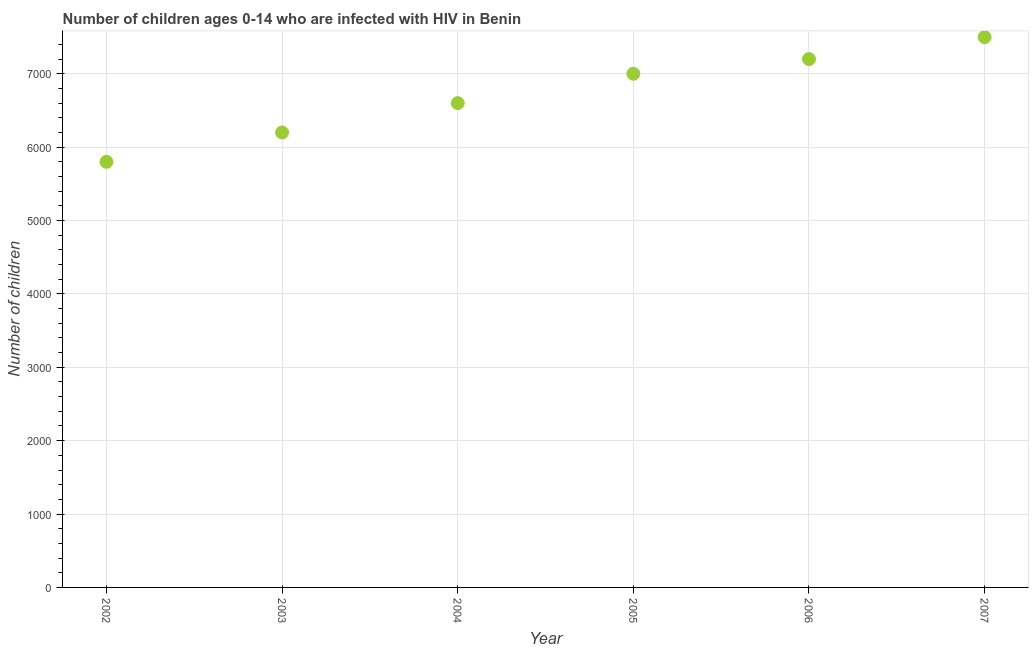What is the number of children living with hiv in 2007?
Offer a very short reply. 7500. Across all years, what is the maximum number of children living with hiv?
Keep it short and to the point. 7500. Across all years, what is the minimum number of children living with hiv?
Make the answer very short. 5800. What is the sum of the number of children living with hiv?
Your answer should be compact. 4.03e+04. What is the difference between the number of children living with hiv in 2004 and 2006?
Offer a very short reply. -600. What is the average number of children living with hiv per year?
Offer a terse response. 6716.67. What is the median number of children living with hiv?
Provide a succinct answer. 6800. Do a majority of the years between 2004 and 2007 (inclusive) have number of children living with hiv greater than 4800 ?
Keep it short and to the point. Yes. What is the ratio of the number of children living with hiv in 2005 to that in 2006?
Make the answer very short. 0.97. Is the difference between the number of children living with hiv in 2003 and 2006 greater than the difference between any two years?
Provide a succinct answer. No. What is the difference between the highest and the second highest number of children living with hiv?
Your response must be concise. 300. What is the difference between the highest and the lowest number of children living with hiv?
Your answer should be compact. 1700. In how many years, is the number of children living with hiv greater than the average number of children living with hiv taken over all years?
Your answer should be compact. 3. Does the number of children living with hiv monotonically increase over the years?
Ensure brevity in your answer.  Yes. What is the difference between two consecutive major ticks on the Y-axis?
Provide a short and direct response. 1000. Are the values on the major ticks of Y-axis written in scientific E-notation?
Your response must be concise. No. Does the graph contain any zero values?
Your answer should be compact. No. Does the graph contain grids?
Make the answer very short. Yes. What is the title of the graph?
Provide a succinct answer. Number of children ages 0-14 who are infected with HIV in Benin. What is the label or title of the X-axis?
Provide a succinct answer. Year. What is the label or title of the Y-axis?
Keep it short and to the point. Number of children. What is the Number of children in 2002?
Offer a terse response. 5800. What is the Number of children in 2003?
Offer a terse response. 6200. What is the Number of children in 2004?
Offer a terse response. 6600. What is the Number of children in 2005?
Provide a short and direct response. 7000. What is the Number of children in 2006?
Ensure brevity in your answer.  7200. What is the Number of children in 2007?
Your answer should be very brief. 7500. What is the difference between the Number of children in 2002 and 2003?
Ensure brevity in your answer.  -400. What is the difference between the Number of children in 2002 and 2004?
Your answer should be very brief. -800. What is the difference between the Number of children in 2002 and 2005?
Keep it short and to the point. -1200. What is the difference between the Number of children in 2002 and 2006?
Your answer should be compact. -1400. What is the difference between the Number of children in 2002 and 2007?
Your answer should be very brief. -1700. What is the difference between the Number of children in 2003 and 2004?
Give a very brief answer. -400. What is the difference between the Number of children in 2003 and 2005?
Offer a very short reply. -800. What is the difference between the Number of children in 2003 and 2006?
Your response must be concise. -1000. What is the difference between the Number of children in 2003 and 2007?
Provide a short and direct response. -1300. What is the difference between the Number of children in 2004 and 2005?
Offer a terse response. -400. What is the difference between the Number of children in 2004 and 2006?
Ensure brevity in your answer.  -600. What is the difference between the Number of children in 2004 and 2007?
Provide a succinct answer. -900. What is the difference between the Number of children in 2005 and 2006?
Provide a succinct answer. -200. What is the difference between the Number of children in 2005 and 2007?
Your answer should be very brief. -500. What is the difference between the Number of children in 2006 and 2007?
Your response must be concise. -300. What is the ratio of the Number of children in 2002 to that in 2003?
Offer a very short reply. 0.94. What is the ratio of the Number of children in 2002 to that in 2004?
Your response must be concise. 0.88. What is the ratio of the Number of children in 2002 to that in 2005?
Provide a succinct answer. 0.83. What is the ratio of the Number of children in 2002 to that in 2006?
Ensure brevity in your answer.  0.81. What is the ratio of the Number of children in 2002 to that in 2007?
Keep it short and to the point. 0.77. What is the ratio of the Number of children in 2003 to that in 2004?
Provide a short and direct response. 0.94. What is the ratio of the Number of children in 2003 to that in 2005?
Provide a short and direct response. 0.89. What is the ratio of the Number of children in 2003 to that in 2006?
Ensure brevity in your answer.  0.86. What is the ratio of the Number of children in 2003 to that in 2007?
Make the answer very short. 0.83. What is the ratio of the Number of children in 2004 to that in 2005?
Offer a terse response. 0.94. What is the ratio of the Number of children in 2004 to that in 2006?
Keep it short and to the point. 0.92. What is the ratio of the Number of children in 2004 to that in 2007?
Your answer should be very brief. 0.88. What is the ratio of the Number of children in 2005 to that in 2007?
Your answer should be very brief. 0.93. 